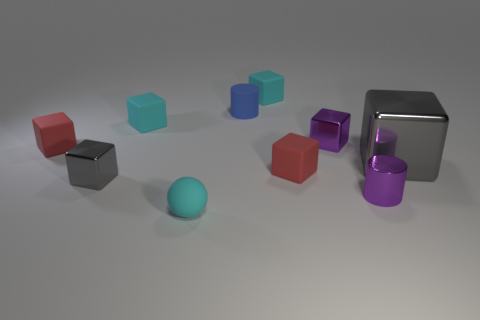Subtract all purple blocks. How many blocks are left? 6 Subtract all red cubes. How many cubes are left? 5 Subtract all red cubes. Subtract all gray spheres. How many cubes are left? 5 Subtract all blocks. How many objects are left? 3 Add 4 gray metallic objects. How many gray metallic objects exist? 6 Subtract 1 purple cylinders. How many objects are left? 9 Subtract all tiny matte balls. Subtract all large red shiny cylinders. How many objects are left? 9 Add 2 gray metallic cubes. How many gray metallic cubes are left? 4 